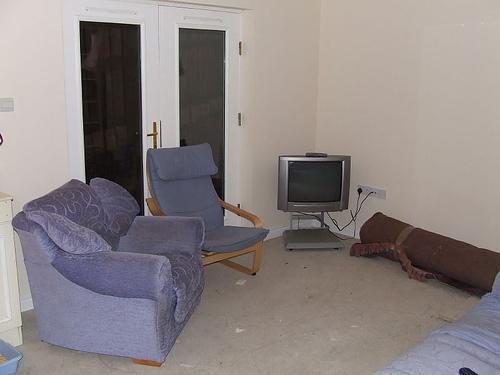How many doors are in this picture?
Give a very brief answer. 2. How many chairs are there?
Give a very brief answer. 2. How many couches are in the photo?
Give a very brief answer. 2. 